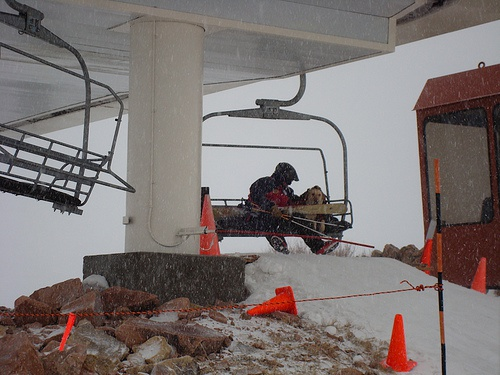Describe the objects in this image and their specific colors. I can see people in gray, black, maroon, and lightgray tones, skis in gray and black tones, and dog in gray, black, and maroon tones in this image. 